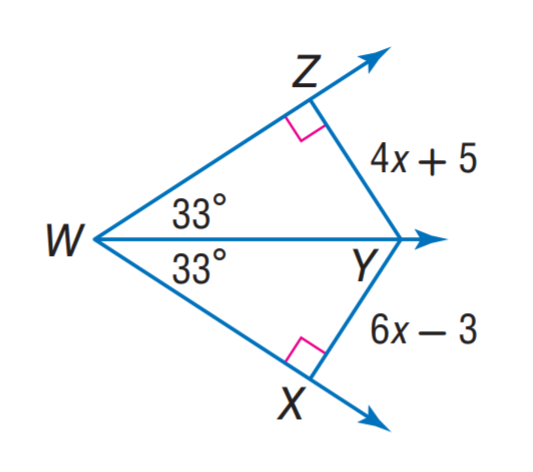Answer the mathemtical geometry problem and directly provide the correct option letter.
Question: Find X Y.
Choices: A: 21 B: 24 C: 33 D: 42 A 